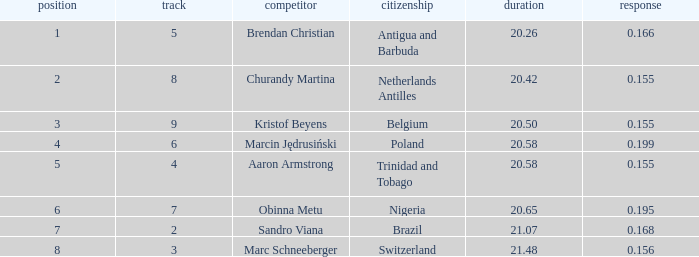How much Time has a Reaction of 0.155, and an Athlete of kristof beyens, and a Rank smaller than 3? 0.0. 